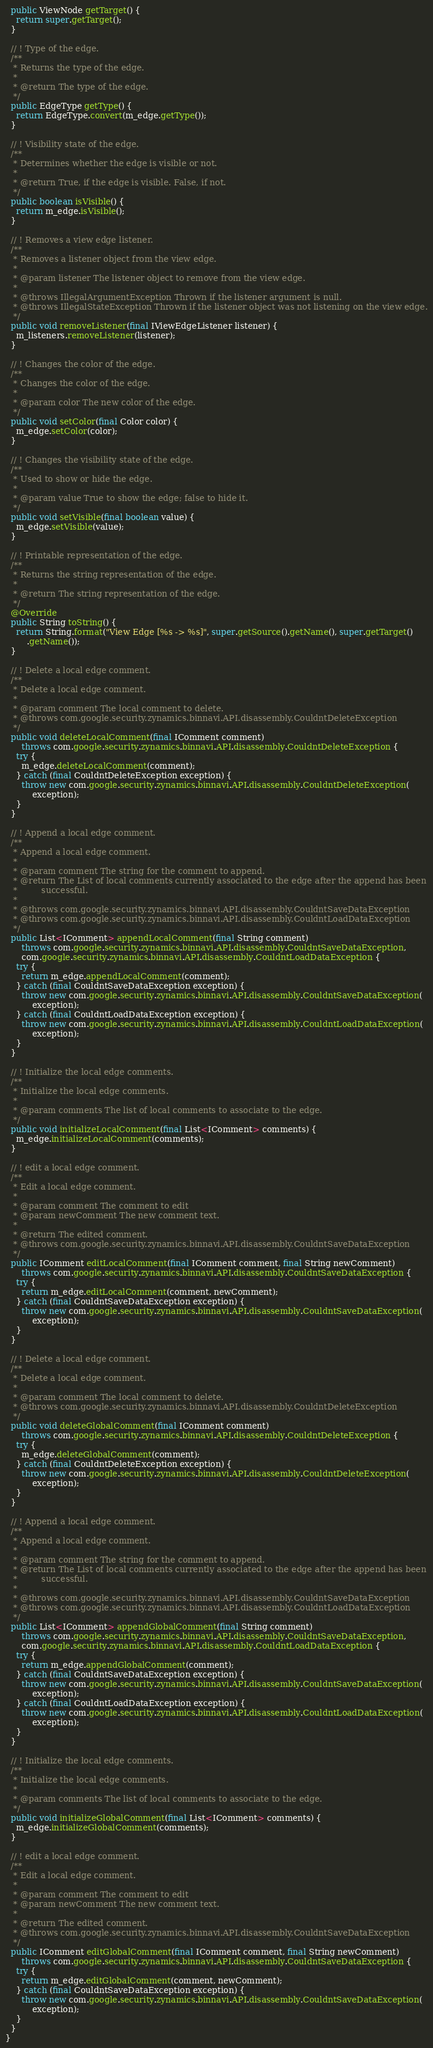<code> <loc_0><loc_0><loc_500><loc_500><_Java_>  public ViewNode getTarget() {
    return super.getTarget();
  }

  // ! Type of the edge.
  /**
   * Returns the type of the edge.
   * 
   * @return The type of the edge.
   */
  public EdgeType getType() {
    return EdgeType.convert(m_edge.getType());
  }

  // ! Visibility state of the edge.
  /**
   * Determines whether the edge is visible or not.
   * 
   * @return True, if the edge is visible. False, if not.
   */
  public boolean isVisible() {
    return m_edge.isVisible();
  }

  // ! Removes a view edge listener.
  /**
   * Removes a listener object from the view edge.
   * 
   * @param listener The listener object to remove from the view edge.
   * 
   * @throws IllegalArgumentException Thrown if the listener argument is null.
   * @throws IllegalStateException Thrown if the listener object was not listening on the view edge.
   */
  public void removeListener(final IViewEdgeListener listener) {
    m_listeners.removeListener(listener);
  }

  // ! Changes the color of the edge.
  /**
   * Changes the color of the edge.
   * 
   * @param color The new color of the edge.
   */
  public void setColor(final Color color) {
    m_edge.setColor(color);
  }

  // ! Changes the visibility state of the edge.
  /**
   * Used to show or hide the edge.
   * 
   * @param value True to show the edge; false to hide it.
   */
  public void setVisible(final boolean value) {
    m_edge.setVisible(value);
  }

  // ! Printable representation of the edge.
  /**
   * Returns the string representation of the edge.
   * 
   * @return The string representation of the edge.
   */
  @Override
  public String toString() {
    return String.format("View Edge [%s -> %s]", super.getSource().getName(), super.getTarget()
        .getName());
  }

  // ! Delete a local edge comment.
  /**
   * Delete a local edge comment.
   * 
   * @param comment The local comment to delete.
   * @throws com.google.security.zynamics.binnavi.API.disassembly.CouldntDeleteException
   */
  public void deleteLocalComment(final IComment comment)
      throws com.google.security.zynamics.binnavi.API.disassembly.CouldntDeleteException {
    try {
      m_edge.deleteLocalComment(comment);
    } catch (final CouldntDeleteException exception) {
      throw new com.google.security.zynamics.binnavi.API.disassembly.CouldntDeleteException(
          exception);
    }
  }

  // ! Append a local edge comment.
  /**
   * Append a local edge comment.
   * 
   * @param comment The string for the comment to append.
   * @return The List of local comments currently associated to the edge after the append has been
   *         successful.
   * 
   * @throws com.google.security.zynamics.binnavi.API.disassembly.CouldntSaveDataException
   * @throws com.google.security.zynamics.binnavi.API.disassembly.CouldntLoadDataException
   */
  public List<IComment> appendLocalComment(final String comment)
      throws com.google.security.zynamics.binnavi.API.disassembly.CouldntSaveDataException,
      com.google.security.zynamics.binnavi.API.disassembly.CouldntLoadDataException {
    try {
      return m_edge.appendLocalComment(comment);
    } catch (final CouldntSaveDataException exception) {
      throw new com.google.security.zynamics.binnavi.API.disassembly.CouldntSaveDataException(
          exception);
    } catch (final CouldntLoadDataException exception) {
      throw new com.google.security.zynamics.binnavi.API.disassembly.CouldntLoadDataException(
          exception);
    }
  }

  // ! Initialize the local edge comments.
  /**
   * Initialize the local edge comments.
   * 
   * @param comments The list of local comments to associate to the edge.
   */
  public void initializeLocalComment(final List<IComment> comments) {
    m_edge.initializeLocalComment(comments);
  }

  // ! edit a local edge comment.
  /**
   * Edit a local edge comment.
   * 
   * @param comment The comment to edit
   * @param newComment The new comment text.
   * 
   * @return The edited comment.
   * @throws com.google.security.zynamics.binnavi.API.disassembly.CouldntSaveDataException
   */
  public IComment editLocalComment(final IComment comment, final String newComment)
      throws com.google.security.zynamics.binnavi.API.disassembly.CouldntSaveDataException {
    try {
      return m_edge.editLocalComment(comment, newComment);
    } catch (final CouldntSaveDataException exception) {
      throw new com.google.security.zynamics.binnavi.API.disassembly.CouldntSaveDataException(
          exception);
    }
  }

  // ! Delete a local edge comment.
  /**
   * Delete a local edge comment.
   * 
   * @param comment The local comment to delete.
   * @throws com.google.security.zynamics.binnavi.API.disassembly.CouldntDeleteException
   */
  public void deleteGlobalComment(final IComment comment)
      throws com.google.security.zynamics.binnavi.API.disassembly.CouldntDeleteException {
    try {
      m_edge.deleteGlobalComment(comment);
    } catch (final CouldntDeleteException exception) {
      throw new com.google.security.zynamics.binnavi.API.disassembly.CouldntDeleteException(
          exception);
    }
  }

  // ! Append a local edge comment.
  /**
   * Append a local edge comment.
   * 
   * @param comment The string for the comment to append.
   * @return The List of local comments currently associated to the edge after the append has been
   *         successful.
   * 
   * @throws com.google.security.zynamics.binnavi.API.disassembly.CouldntSaveDataException
   * @throws com.google.security.zynamics.binnavi.API.disassembly.CouldntLoadDataException
   */
  public List<IComment> appendGlobalComment(final String comment)
      throws com.google.security.zynamics.binnavi.API.disassembly.CouldntSaveDataException,
      com.google.security.zynamics.binnavi.API.disassembly.CouldntLoadDataException {
    try {
      return m_edge.appendGlobalComment(comment);
    } catch (final CouldntSaveDataException exception) {
      throw new com.google.security.zynamics.binnavi.API.disassembly.CouldntSaveDataException(
          exception);
    } catch (final CouldntLoadDataException exception) {
      throw new com.google.security.zynamics.binnavi.API.disassembly.CouldntLoadDataException(
          exception);
    }
  }

  // ! Initialize the local edge comments.
  /**
   * Initialize the local edge comments.
   * 
   * @param comments The list of local comments to associate to the edge.
   */
  public void initializeGlobalComment(final List<IComment> comments) {
    m_edge.initializeGlobalComment(comments);
  }

  // ! edit a local edge comment.
  /**
   * Edit a local edge comment.
   * 
   * @param comment The comment to edit
   * @param newComment The new comment text.
   * 
   * @return The edited comment.
   * @throws com.google.security.zynamics.binnavi.API.disassembly.CouldntSaveDataException
   */
  public IComment editGlobalComment(final IComment comment, final String newComment)
      throws com.google.security.zynamics.binnavi.API.disassembly.CouldntSaveDataException {
    try {
      return m_edge.editGlobalComment(comment, newComment);
    } catch (final CouldntSaveDataException exception) {
      throw new com.google.security.zynamics.binnavi.API.disassembly.CouldntSaveDataException(
          exception);
    }
  }
}
</code> 